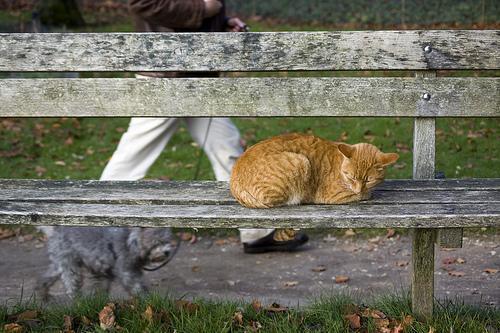How many cats are there?
Give a very brief answer. 1. How many brown cats are there?
Give a very brief answer. 1. How many animals are on a leash?
Give a very brief answer. 1. How many cats are on the bench?
Give a very brief answer. 1. 